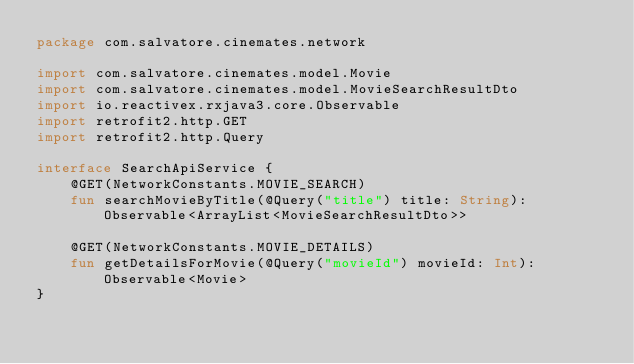Convert code to text. <code><loc_0><loc_0><loc_500><loc_500><_Kotlin_>package com.salvatore.cinemates.network

import com.salvatore.cinemates.model.Movie
import com.salvatore.cinemates.model.MovieSearchResultDto
import io.reactivex.rxjava3.core.Observable
import retrofit2.http.GET
import retrofit2.http.Query

interface SearchApiService {
    @GET(NetworkConstants.MOVIE_SEARCH)
    fun searchMovieByTitle(@Query("title") title: String): Observable<ArrayList<MovieSearchResultDto>>

    @GET(NetworkConstants.MOVIE_DETAILS)
    fun getDetailsForMovie(@Query("movieId") movieId: Int): Observable<Movie>
}</code> 